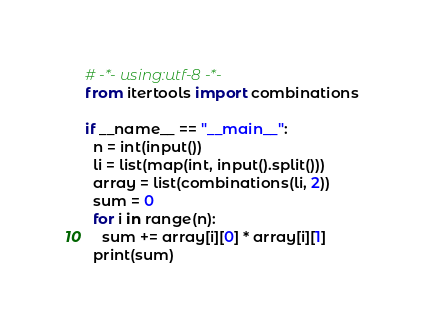Convert code to text. <code><loc_0><loc_0><loc_500><loc_500><_Python_># -*- using:utf-8 -*-
from itertools import combinations

if __name__ == "__main__":
  n = int(input())
  li = list(map(int, input().split()))
  array = list(combinations(li, 2))
  sum = 0
  for i in range(n):
    sum += array[i][0] * array[i][1]
  print(sum)</code> 